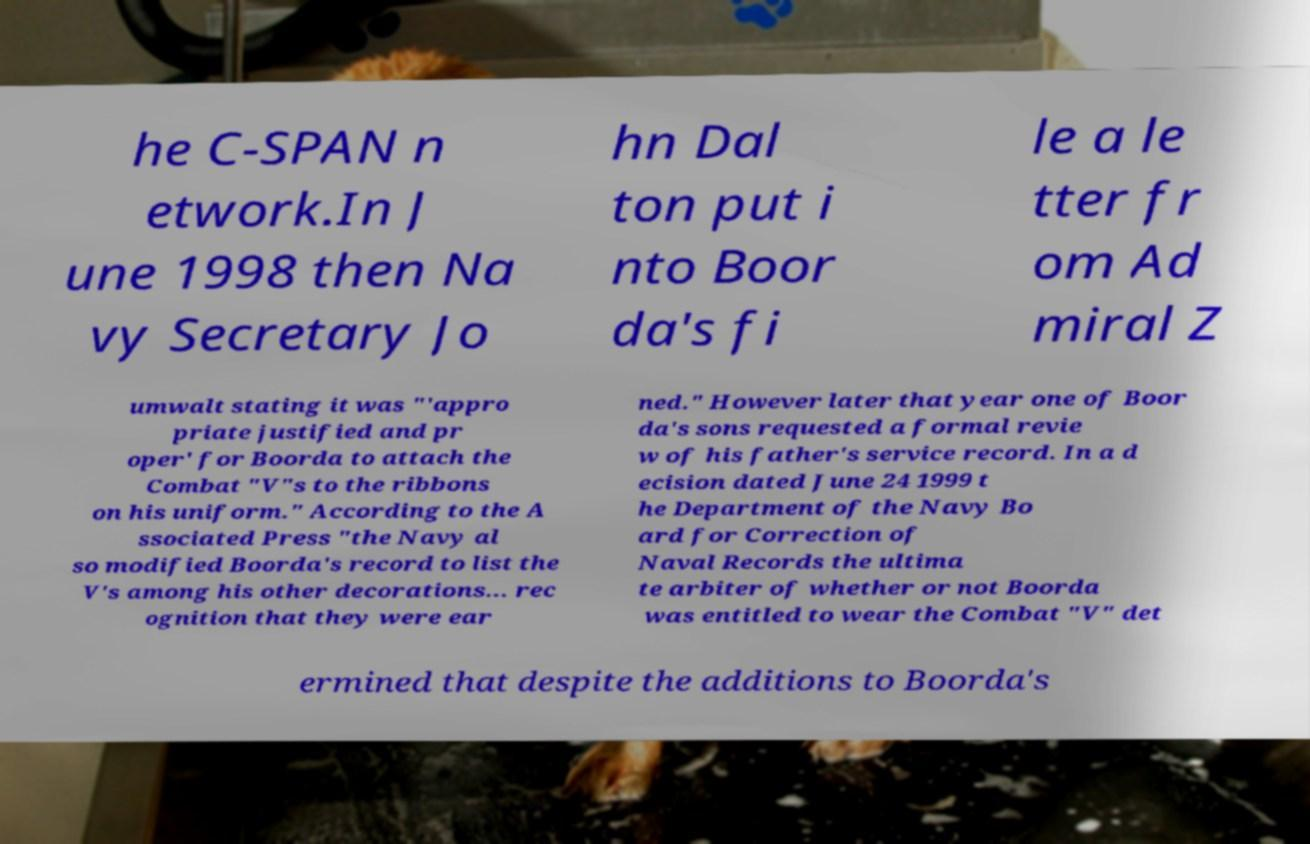Can you read and provide the text displayed in the image?This photo seems to have some interesting text. Can you extract and type it out for me? he C-SPAN n etwork.In J une 1998 then Na vy Secretary Jo hn Dal ton put i nto Boor da's fi le a le tter fr om Ad miral Z umwalt stating it was "'appro priate justified and pr oper' for Boorda to attach the Combat "V"s to the ribbons on his uniform." According to the A ssociated Press "the Navy al so modified Boorda's record to list the V's among his other decorations... rec ognition that they were ear ned." However later that year one of Boor da's sons requested a formal revie w of his father's service record. In a d ecision dated June 24 1999 t he Department of the Navy Bo ard for Correction of Naval Records the ultima te arbiter of whether or not Boorda was entitled to wear the Combat "V" det ermined that despite the additions to Boorda's 